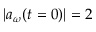<formula> <loc_0><loc_0><loc_500><loc_500>| a _ { \omega } ( t = 0 ) | = 2</formula> 